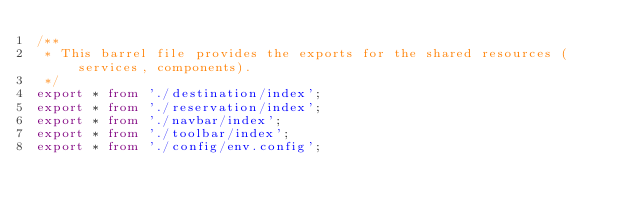<code> <loc_0><loc_0><loc_500><loc_500><_TypeScript_>/**
 * This barrel file provides the exports for the shared resources (services, components).
 */
export * from './destination/index';
export * from './reservation/index';
export * from './navbar/index';
export * from './toolbar/index';
export * from './config/env.config';
</code> 